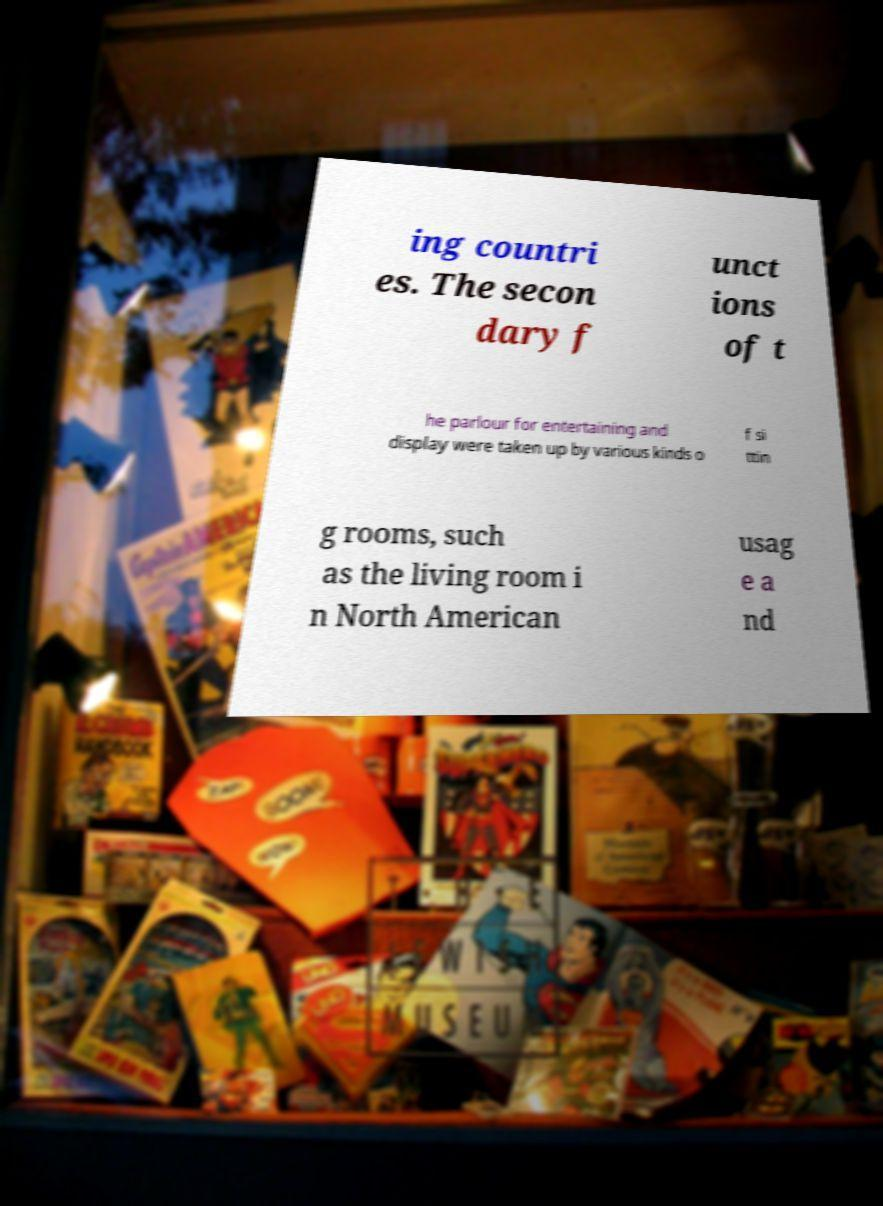Please read and relay the text visible in this image. What does it say? ing countri es. The secon dary f unct ions of t he parlour for entertaining and display were taken up by various kinds o f si ttin g rooms, such as the living room i n North American usag e a nd 